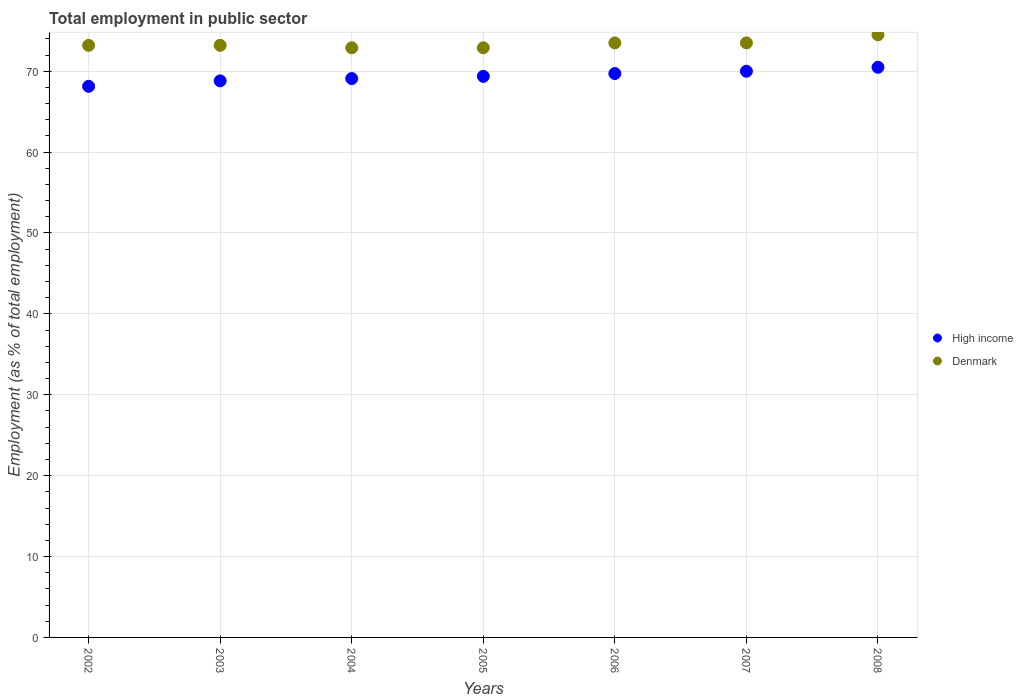Is the number of dotlines equal to the number of legend labels?
Your response must be concise. Yes. What is the employment in public sector in Denmark in 2008?
Your answer should be compact. 74.5. Across all years, what is the maximum employment in public sector in High income?
Your answer should be compact. 70.49. Across all years, what is the minimum employment in public sector in Denmark?
Your answer should be compact. 72.9. In which year was the employment in public sector in High income minimum?
Ensure brevity in your answer.  2002. What is the total employment in public sector in Denmark in the graph?
Ensure brevity in your answer.  513.7. What is the difference between the employment in public sector in High income in 2004 and that in 2008?
Your response must be concise. -1.4. What is the difference between the employment in public sector in High income in 2004 and the employment in public sector in Denmark in 2002?
Your answer should be compact. -4.11. What is the average employment in public sector in High income per year?
Your answer should be compact. 69.37. In the year 2002, what is the difference between the employment in public sector in Denmark and employment in public sector in High income?
Offer a very short reply. 5.07. In how many years, is the employment in public sector in High income greater than 48 %?
Ensure brevity in your answer.  7. What is the ratio of the employment in public sector in High income in 2002 to that in 2003?
Keep it short and to the point. 0.99. Is the difference between the employment in public sector in Denmark in 2002 and 2005 greater than the difference between the employment in public sector in High income in 2002 and 2005?
Give a very brief answer. Yes. What is the difference between the highest and the second highest employment in public sector in High income?
Offer a very short reply. 0.49. What is the difference between the highest and the lowest employment in public sector in High income?
Your answer should be compact. 2.36. In how many years, is the employment in public sector in High income greater than the average employment in public sector in High income taken over all years?
Ensure brevity in your answer.  3. Is the employment in public sector in High income strictly greater than the employment in public sector in Denmark over the years?
Offer a terse response. No. Is the employment in public sector in High income strictly less than the employment in public sector in Denmark over the years?
Your response must be concise. Yes. How many dotlines are there?
Your answer should be very brief. 2. What is the difference between two consecutive major ticks on the Y-axis?
Offer a terse response. 10. Are the values on the major ticks of Y-axis written in scientific E-notation?
Give a very brief answer. No. Does the graph contain any zero values?
Ensure brevity in your answer.  No. What is the title of the graph?
Your response must be concise. Total employment in public sector. Does "Belarus" appear as one of the legend labels in the graph?
Offer a terse response. No. What is the label or title of the X-axis?
Offer a terse response. Years. What is the label or title of the Y-axis?
Keep it short and to the point. Employment (as % of total employment). What is the Employment (as % of total employment) in High income in 2002?
Your answer should be compact. 68.13. What is the Employment (as % of total employment) in Denmark in 2002?
Provide a short and direct response. 73.2. What is the Employment (as % of total employment) in High income in 2003?
Ensure brevity in your answer.  68.81. What is the Employment (as % of total employment) in Denmark in 2003?
Offer a terse response. 73.2. What is the Employment (as % of total employment) of High income in 2004?
Keep it short and to the point. 69.09. What is the Employment (as % of total employment) of Denmark in 2004?
Your answer should be very brief. 72.9. What is the Employment (as % of total employment) of High income in 2005?
Your answer should be compact. 69.36. What is the Employment (as % of total employment) in Denmark in 2005?
Offer a very short reply. 72.9. What is the Employment (as % of total employment) in High income in 2006?
Your response must be concise. 69.71. What is the Employment (as % of total employment) of Denmark in 2006?
Give a very brief answer. 73.5. What is the Employment (as % of total employment) of High income in 2007?
Offer a terse response. 70. What is the Employment (as % of total employment) in Denmark in 2007?
Ensure brevity in your answer.  73.5. What is the Employment (as % of total employment) of High income in 2008?
Your answer should be very brief. 70.49. What is the Employment (as % of total employment) of Denmark in 2008?
Keep it short and to the point. 74.5. Across all years, what is the maximum Employment (as % of total employment) of High income?
Your answer should be very brief. 70.49. Across all years, what is the maximum Employment (as % of total employment) of Denmark?
Ensure brevity in your answer.  74.5. Across all years, what is the minimum Employment (as % of total employment) of High income?
Offer a very short reply. 68.13. Across all years, what is the minimum Employment (as % of total employment) in Denmark?
Offer a terse response. 72.9. What is the total Employment (as % of total employment) of High income in the graph?
Offer a terse response. 485.6. What is the total Employment (as % of total employment) of Denmark in the graph?
Ensure brevity in your answer.  513.7. What is the difference between the Employment (as % of total employment) of High income in 2002 and that in 2003?
Your response must be concise. -0.68. What is the difference between the Employment (as % of total employment) in High income in 2002 and that in 2004?
Your answer should be very brief. -0.96. What is the difference between the Employment (as % of total employment) of Denmark in 2002 and that in 2004?
Offer a terse response. 0.3. What is the difference between the Employment (as % of total employment) of High income in 2002 and that in 2005?
Keep it short and to the point. -1.23. What is the difference between the Employment (as % of total employment) of High income in 2002 and that in 2006?
Provide a succinct answer. -1.58. What is the difference between the Employment (as % of total employment) in High income in 2002 and that in 2007?
Your answer should be compact. -1.87. What is the difference between the Employment (as % of total employment) of Denmark in 2002 and that in 2007?
Provide a short and direct response. -0.3. What is the difference between the Employment (as % of total employment) of High income in 2002 and that in 2008?
Your response must be concise. -2.36. What is the difference between the Employment (as % of total employment) in Denmark in 2002 and that in 2008?
Offer a terse response. -1.3. What is the difference between the Employment (as % of total employment) of High income in 2003 and that in 2004?
Ensure brevity in your answer.  -0.28. What is the difference between the Employment (as % of total employment) of Denmark in 2003 and that in 2004?
Your answer should be compact. 0.3. What is the difference between the Employment (as % of total employment) of High income in 2003 and that in 2005?
Offer a very short reply. -0.56. What is the difference between the Employment (as % of total employment) of Denmark in 2003 and that in 2005?
Your answer should be compact. 0.3. What is the difference between the Employment (as % of total employment) of High income in 2003 and that in 2006?
Provide a succinct answer. -0.91. What is the difference between the Employment (as % of total employment) of Denmark in 2003 and that in 2006?
Offer a very short reply. -0.3. What is the difference between the Employment (as % of total employment) of High income in 2003 and that in 2007?
Provide a short and direct response. -1.19. What is the difference between the Employment (as % of total employment) in High income in 2003 and that in 2008?
Your response must be concise. -1.68. What is the difference between the Employment (as % of total employment) of High income in 2004 and that in 2005?
Offer a very short reply. -0.27. What is the difference between the Employment (as % of total employment) of High income in 2004 and that in 2006?
Your answer should be very brief. -0.62. What is the difference between the Employment (as % of total employment) of High income in 2004 and that in 2007?
Make the answer very short. -0.91. What is the difference between the Employment (as % of total employment) of Denmark in 2004 and that in 2007?
Provide a succinct answer. -0.6. What is the difference between the Employment (as % of total employment) in High income in 2004 and that in 2008?
Provide a short and direct response. -1.4. What is the difference between the Employment (as % of total employment) of High income in 2005 and that in 2006?
Ensure brevity in your answer.  -0.35. What is the difference between the Employment (as % of total employment) of High income in 2005 and that in 2007?
Offer a very short reply. -0.63. What is the difference between the Employment (as % of total employment) of High income in 2005 and that in 2008?
Your answer should be very brief. -1.12. What is the difference between the Employment (as % of total employment) of High income in 2006 and that in 2007?
Offer a terse response. -0.28. What is the difference between the Employment (as % of total employment) in High income in 2006 and that in 2008?
Keep it short and to the point. -0.77. What is the difference between the Employment (as % of total employment) in Denmark in 2006 and that in 2008?
Provide a short and direct response. -1. What is the difference between the Employment (as % of total employment) of High income in 2007 and that in 2008?
Offer a terse response. -0.49. What is the difference between the Employment (as % of total employment) of High income in 2002 and the Employment (as % of total employment) of Denmark in 2003?
Your response must be concise. -5.07. What is the difference between the Employment (as % of total employment) of High income in 2002 and the Employment (as % of total employment) of Denmark in 2004?
Your response must be concise. -4.77. What is the difference between the Employment (as % of total employment) in High income in 2002 and the Employment (as % of total employment) in Denmark in 2005?
Your answer should be compact. -4.77. What is the difference between the Employment (as % of total employment) of High income in 2002 and the Employment (as % of total employment) of Denmark in 2006?
Give a very brief answer. -5.37. What is the difference between the Employment (as % of total employment) of High income in 2002 and the Employment (as % of total employment) of Denmark in 2007?
Give a very brief answer. -5.37. What is the difference between the Employment (as % of total employment) of High income in 2002 and the Employment (as % of total employment) of Denmark in 2008?
Provide a succinct answer. -6.37. What is the difference between the Employment (as % of total employment) of High income in 2003 and the Employment (as % of total employment) of Denmark in 2004?
Your response must be concise. -4.09. What is the difference between the Employment (as % of total employment) of High income in 2003 and the Employment (as % of total employment) of Denmark in 2005?
Ensure brevity in your answer.  -4.09. What is the difference between the Employment (as % of total employment) of High income in 2003 and the Employment (as % of total employment) of Denmark in 2006?
Make the answer very short. -4.69. What is the difference between the Employment (as % of total employment) in High income in 2003 and the Employment (as % of total employment) in Denmark in 2007?
Provide a succinct answer. -4.69. What is the difference between the Employment (as % of total employment) in High income in 2003 and the Employment (as % of total employment) in Denmark in 2008?
Ensure brevity in your answer.  -5.69. What is the difference between the Employment (as % of total employment) of High income in 2004 and the Employment (as % of total employment) of Denmark in 2005?
Your response must be concise. -3.81. What is the difference between the Employment (as % of total employment) in High income in 2004 and the Employment (as % of total employment) in Denmark in 2006?
Offer a very short reply. -4.41. What is the difference between the Employment (as % of total employment) in High income in 2004 and the Employment (as % of total employment) in Denmark in 2007?
Offer a terse response. -4.41. What is the difference between the Employment (as % of total employment) of High income in 2004 and the Employment (as % of total employment) of Denmark in 2008?
Keep it short and to the point. -5.41. What is the difference between the Employment (as % of total employment) in High income in 2005 and the Employment (as % of total employment) in Denmark in 2006?
Give a very brief answer. -4.14. What is the difference between the Employment (as % of total employment) in High income in 2005 and the Employment (as % of total employment) in Denmark in 2007?
Provide a short and direct response. -4.14. What is the difference between the Employment (as % of total employment) in High income in 2005 and the Employment (as % of total employment) in Denmark in 2008?
Your answer should be very brief. -5.14. What is the difference between the Employment (as % of total employment) in High income in 2006 and the Employment (as % of total employment) in Denmark in 2007?
Give a very brief answer. -3.79. What is the difference between the Employment (as % of total employment) of High income in 2006 and the Employment (as % of total employment) of Denmark in 2008?
Your response must be concise. -4.79. What is the difference between the Employment (as % of total employment) in High income in 2007 and the Employment (as % of total employment) in Denmark in 2008?
Keep it short and to the point. -4.5. What is the average Employment (as % of total employment) in High income per year?
Make the answer very short. 69.37. What is the average Employment (as % of total employment) in Denmark per year?
Offer a very short reply. 73.39. In the year 2002, what is the difference between the Employment (as % of total employment) of High income and Employment (as % of total employment) of Denmark?
Ensure brevity in your answer.  -5.07. In the year 2003, what is the difference between the Employment (as % of total employment) of High income and Employment (as % of total employment) of Denmark?
Provide a succinct answer. -4.39. In the year 2004, what is the difference between the Employment (as % of total employment) in High income and Employment (as % of total employment) in Denmark?
Provide a short and direct response. -3.81. In the year 2005, what is the difference between the Employment (as % of total employment) of High income and Employment (as % of total employment) of Denmark?
Keep it short and to the point. -3.54. In the year 2006, what is the difference between the Employment (as % of total employment) in High income and Employment (as % of total employment) in Denmark?
Keep it short and to the point. -3.79. In the year 2007, what is the difference between the Employment (as % of total employment) in High income and Employment (as % of total employment) in Denmark?
Provide a succinct answer. -3.5. In the year 2008, what is the difference between the Employment (as % of total employment) in High income and Employment (as % of total employment) in Denmark?
Make the answer very short. -4.01. What is the ratio of the Employment (as % of total employment) of High income in 2002 to that in 2003?
Keep it short and to the point. 0.99. What is the ratio of the Employment (as % of total employment) of High income in 2002 to that in 2004?
Your answer should be very brief. 0.99. What is the ratio of the Employment (as % of total employment) of High income in 2002 to that in 2005?
Your answer should be compact. 0.98. What is the ratio of the Employment (as % of total employment) of High income in 2002 to that in 2006?
Give a very brief answer. 0.98. What is the ratio of the Employment (as % of total employment) in Denmark in 2002 to that in 2006?
Your answer should be compact. 1. What is the ratio of the Employment (as % of total employment) of High income in 2002 to that in 2007?
Give a very brief answer. 0.97. What is the ratio of the Employment (as % of total employment) in Denmark in 2002 to that in 2007?
Keep it short and to the point. 1. What is the ratio of the Employment (as % of total employment) in High income in 2002 to that in 2008?
Your answer should be compact. 0.97. What is the ratio of the Employment (as % of total employment) of Denmark in 2002 to that in 2008?
Your response must be concise. 0.98. What is the ratio of the Employment (as % of total employment) of High income in 2003 to that in 2004?
Your answer should be very brief. 1. What is the ratio of the Employment (as % of total employment) of High income in 2003 to that in 2005?
Ensure brevity in your answer.  0.99. What is the ratio of the Employment (as % of total employment) of Denmark in 2003 to that in 2005?
Your response must be concise. 1. What is the ratio of the Employment (as % of total employment) in High income in 2003 to that in 2006?
Give a very brief answer. 0.99. What is the ratio of the Employment (as % of total employment) of High income in 2003 to that in 2007?
Provide a succinct answer. 0.98. What is the ratio of the Employment (as % of total employment) of Denmark in 2003 to that in 2007?
Provide a succinct answer. 1. What is the ratio of the Employment (as % of total employment) of High income in 2003 to that in 2008?
Make the answer very short. 0.98. What is the ratio of the Employment (as % of total employment) of Denmark in 2003 to that in 2008?
Give a very brief answer. 0.98. What is the ratio of the Employment (as % of total employment) in Denmark in 2004 to that in 2005?
Provide a short and direct response. 1. What is the ratio of the Employment (as % of total employment) in Denmark in 2004 to that in 2006?
Make the answer very short. 0.99. What is the ratio of the Employment (as % of total employment) of High income in 2004 to that in 2007?
Your answer should be very brief. 0.99. What is the ratio of the Employment (as % of total employment) in High income in 2004 to that in 2008?
Provide a short and direct response. 0.98. What is the ratio of the Employment (as % of total employment) in Denmark in 2004 to that in 2008?
Keep it short and to the point. 0.98. What is the ratio of the Employment (as % of total employment) of High income in 2005 to that in 2006?
Provide a succinct answer. 0.99. What is the ratio of the Employment (as % of total employment) of Denmark in 2005 to that in 2006?
Make the answer very short. 0.99. What is the ratio of the Employment (as % of total employment) in High income in 2005 to that in 2007?
Your answer should be compact. 0.99. What is the ratio of the Employment (as % of total employment) of Denmark in 2005 to that in 2007?
Provide a succinct answer. 0.99. What is the ratio of the Employment (as % of total employment) in High income in 2005 to that in 2008?
Your response must be concise. 0.98. What is the ratio of the Employment (as % of total employment) of Denmark in 2005 to that in 2008?
Your answer should be compact. 0.98. What is the ratio of the Employment (as % of total employment) of High income in 2006 to that in 2007?
Your answer should be very brief. 1. What is the ratio of the Employment (as % of total employment) of High income in 2006 to that in 2008?
Your answer should be compact. 0.99. What is the ratio of the Employment (as % of total employment) in Denmark in 2006 to that in 2008?
Keep it short and to the point. 0.99. What is the ratio of the Employment (as % of total employment) in Denmark in 2007 to that in 2008?
Your response must be concise. 0.99. What is the difference between the highest and the second highest Employment (as % of total employment) of High income?
Your response must be concise. 0.49. What is the difference between the highest and the second highest Employment (as % of total employment) in Denmark?
Offer a very short reply. 1. What is the difference between the highest and the lowest Employment (as % of total employment) in High income?
Provide a succinct answer. 2.36. What is the difference between the highest and the lowest Employment (as % of total employment) in Denmark?
Keep it short and to the point. 1.6. 